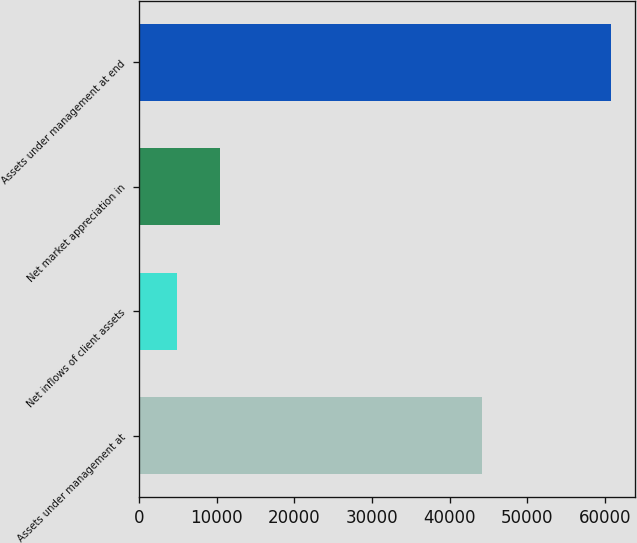<chart> <loc_0><loc_0><loc_500><loc_500><bar_chart><fcel>Assets under management at<fcel>Net inflows of client assets<fcel>Net market appreciation in<fcel>Assets under management at end<nl><fcel>44168<fcel>4873<fcel>10464.5<fcel>60788<nl></chart> 